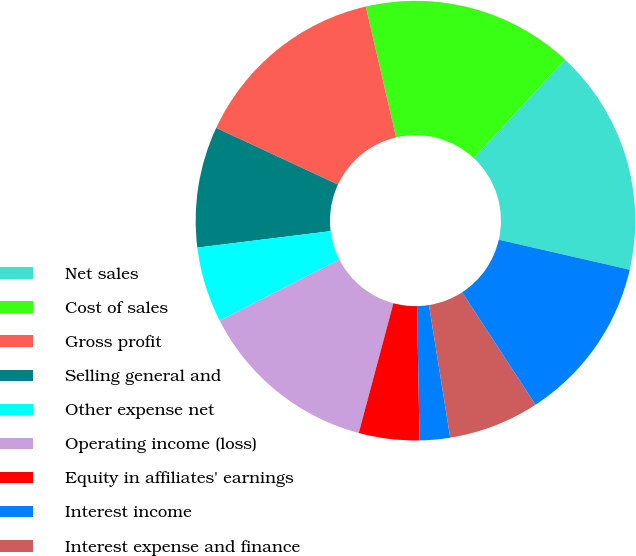<chart> <loc_0><loc_0><loc_500><loc_500><pie_chart><fcel>Net sales<fcel>Cost of sales<fcel>Gross profit<fcel>Selling general and<fcel>Other expense net<fcel>Operating income (loss)<fcel>Equity in affiliates' earnings<fcel>Interest income<fcel>Interest expense and finance<fcel>Earnings (loss) before income<nl><fcel>16.66%<fcel>15.55%<fcel>14.44%<fcel>8.89%<fcel>5.56%<fcel>13.33%<fcel>4.45%<fcel>2.23%<fcel>6.67%<fcel>12.22%<nl></chart> 